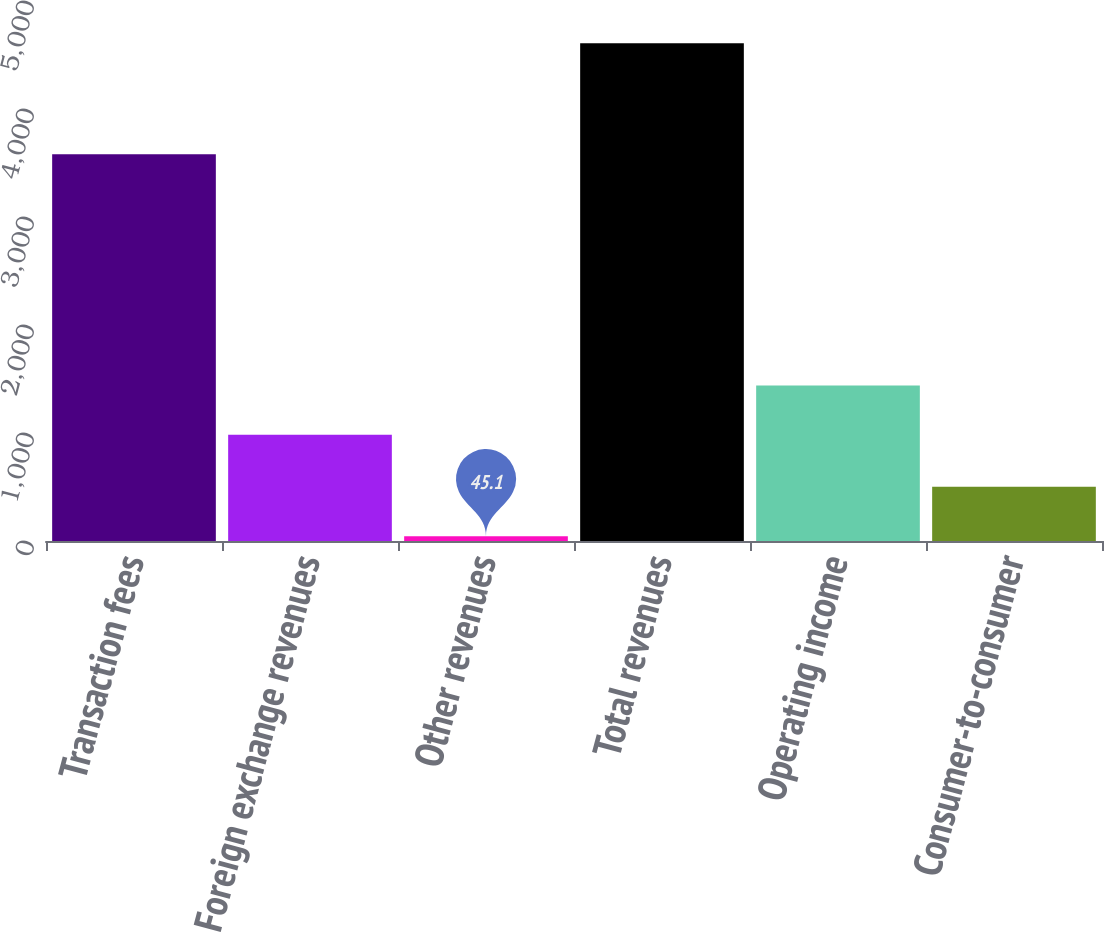<chart> <loc_0><loc_0><loc_500><loc_500><bar_chart><fcel>Transaction fees<fcel>Foreign exchange revenues<fcel>Other revenues<fcel>Total revenues<fcel>Operating income<fcel>Consumer-to-consumer<nl><fcel>3580.2<fcel>983.1<fcel>45.1<fcel>4608.4<fcel>1439.43<fcel>501.43<nl></chart> 